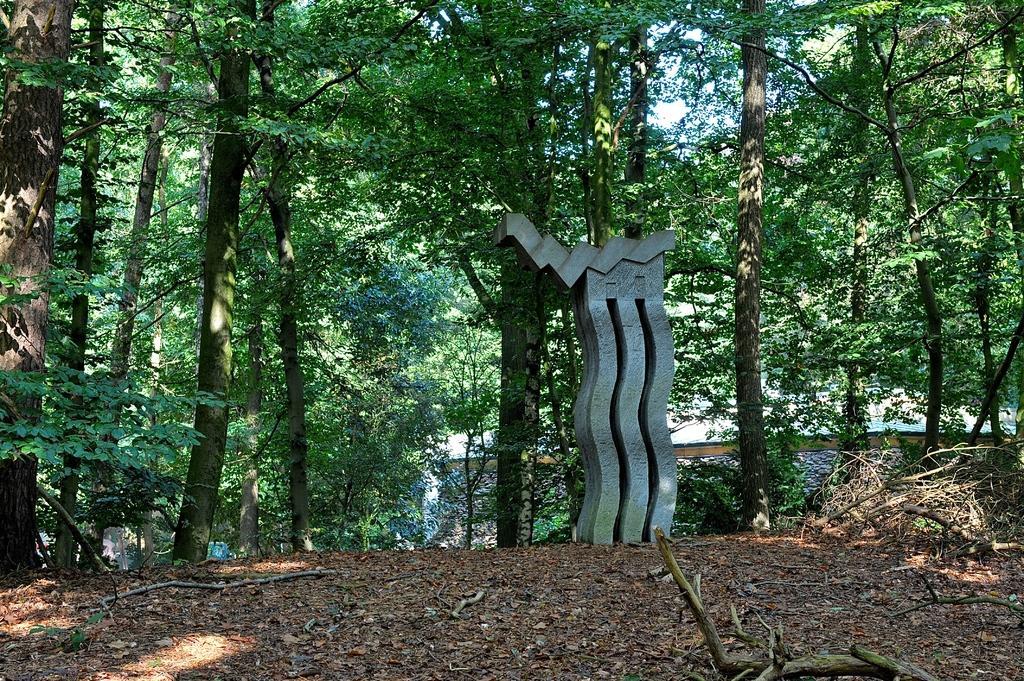Describe this image in one or two sentences. In the image there are many dry leaves on the soil in the foreground and there is some object, around that object there are many trees. 